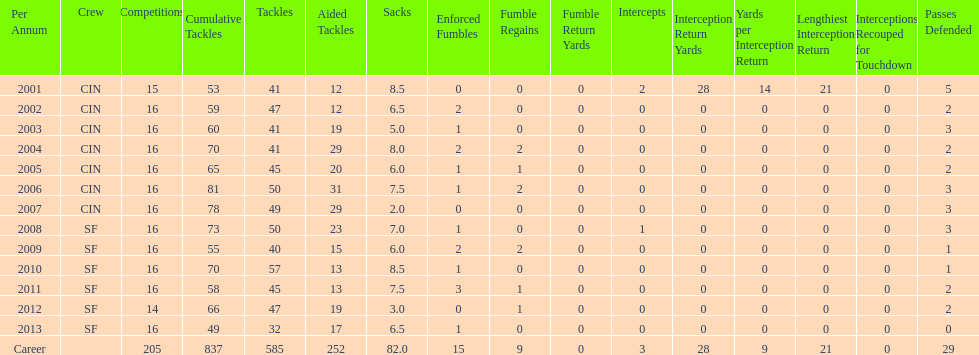Can you parse all the data within this table? {'header': ['Per Annum', 'Crew', 'Competitions', 'Cumulative Tackles', 'Tackles', 'Aided Tackles', 'Sacks', 'Enforced Fumbles', 'Fumble Regains', 'Fumble Return Yards', 'Intercepts', 'Interception Return Yards', 'Yards per Interception Return', 'Lengthiest Interception Return', 'Interceptions Recouped for Touchdown', 'Passes Defended'], 'rows': [['2001', 'CIN', '15', '53', '41', '12', '8.5', '0', '0', '0', '2', '28', '14', '21', '0', '5'], ['2002', 'CIN', '16', '59', '47', '12', '6.5', '2', '0', '0', '0', '0', '0', '0', '0', '2'], ['2003', 'CIN', '16', '60', '41', '19', '5.0', '1', '0', '0', '0', '0', '0', '0', '0', '3'], ['2004', 'CIN', '16', '70', '41', '29', '8.0', '2', '2', '0', '0', '0', '0', '0', '0', '2'], ['2005', 'CIN', '16', '65', '45', '20', '6.0', '1', '1', '0', '0', '0', '0', '0', '0', '2'], ['2006', 'CIN', '16', '81', '50', '31', '7.5', '1', '2', '0', '0', '0', '0', '0', '0', '3'], ['2007', 'CIN', '16', '78', '49', '29', '2.0', '0', '0', '0', '0', '0', '0', '0', '0', '3'], ['2008', 'SF', '16', '73', '50', '23', '7.0', '1', '0', '0', '1', '0', '0', '0', '0', '3'], ['2009', 'SF', '16', '55', '40', '15', '6.0', '2', '2', '0', '0', '0', '0', '0', '0', '1'], ['2010', 'SF', '16', '70', '57', '13', '8.5', '1', '0', '0', '0', '0', '0', '0', '0', '1'], ['2011', 'SF', '16', '58', '45', '13', '7.5', '3', '1', '0', '0', '0', '0', '0', '0', '2'], ['2012', 'SF', '14', '66', '47', '19', '3.0', '0', '1', '0', '0', '0', '0', '0', '0', '2'], ['2013', 'SF', '16', '49', '32', '17', '6.5', '1', '0', '0', '0', '0', '0', '0', '0', '0'], ['Career', '', '205', '837', '585', '252', '82.0', '15', '9', '0', '3', '28', '9', '21', '0', '29']]} What is the average number of tackles this player has had over his career? 45. 